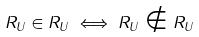<formula> <loc_0><loc_0><loc_500><loc_500>R _ { U } \in R _ { U } \iff R _ { U } \notin R _ { U }</formula> 